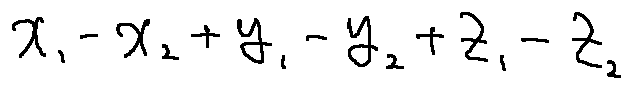<formula> <loc_0><loc_0><loc_500><loc_500>x _ { 1 } - x _ { 2 } + y _ { 1 } - y _ { 2 } + z _ { 1 } - z _ { 2 }</formula> 